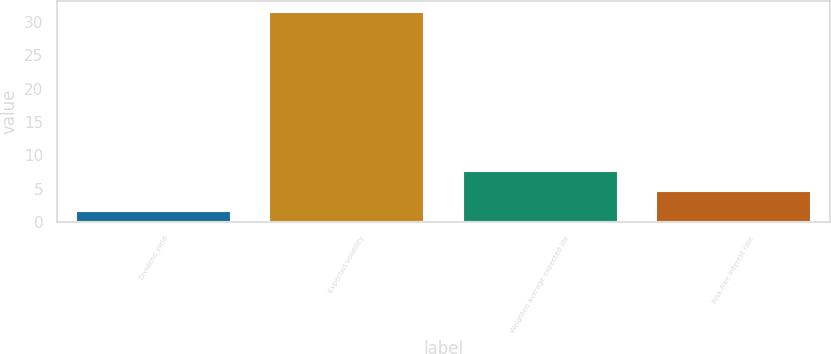Convert chart to OTSL. <chart><loc_0><loc_0><loc_500><loc_500><bar_chart><fcel>Dividend yield<fcel>Expected volatility<fcel>Weighted average expected life<fcel>Risk-free interest rate<nl><fcel>1.6<fcel>31.5<fcel>7.58<fcel>4.59<nl></chart> 